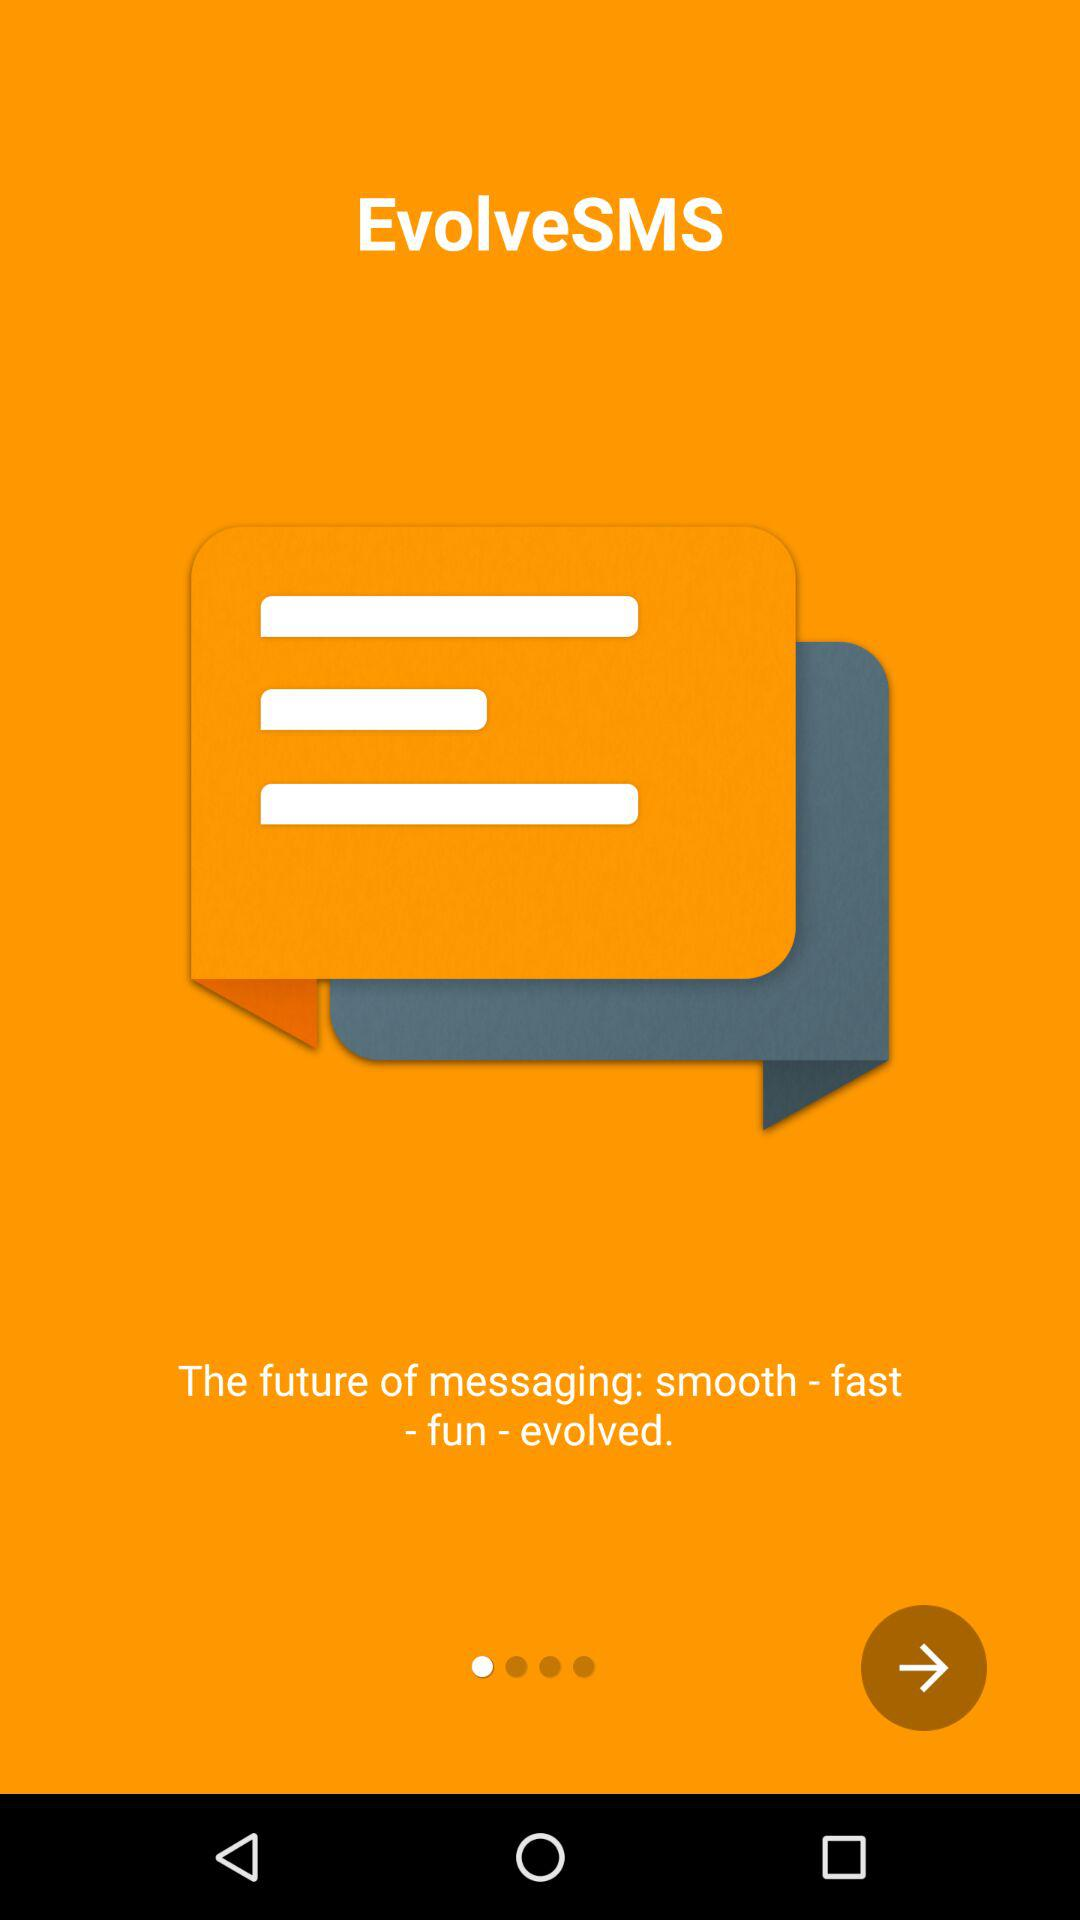What is the name of the application? The name of the application is "EvolveSMS". 